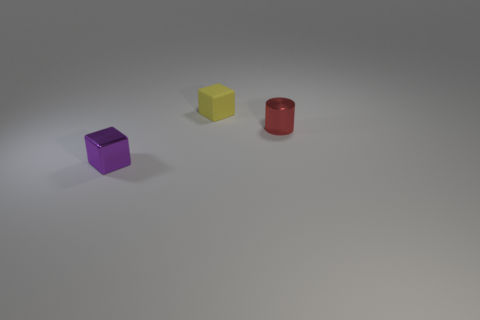Add 3 purple things. How many objects exist? 6 Subtract all cubes. How many objects are left? 1 Subtract all brown shiny balls. Subtract all shiny objects. How many objects are left? 1 Add 3 small yellow things. How many small yellow things are left? 4 Add 3 small matte objects. How many small matte objects exist? 4 Subtract 1 purple blocks. How many objects are left? 2 